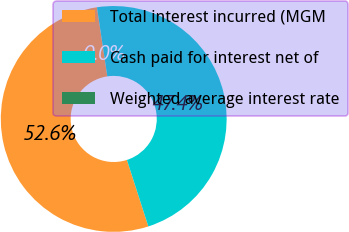Convert chart. <chart><loc_0><loc_0><loc_500><loc_500><pie_chart><fcel>Total interest incurred (MGM<fcel>Cash paid for interest net of<fcel>Weighted average interest rate<nl><fcel>52.59%<fcel>47.41%<fcel>0.0%<nl></chart> 